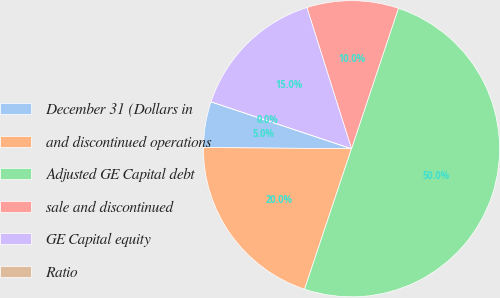Convert chart. <chart><loc_0><loc_0><loc_500><loc_500><pie_chart><fcel>December 31 (Dollars in<fcel>and discontinued operations<fcel>Adjusted GE Capital debt<fcel>sale and discontinued<fcel>GE Capital equity<fcel>Ratio<nl><fcel>5.0%<fcel>20.0%<fcel>50.0%<fcel>10.0%<fcel>15.0%<fcel>0.0%<nl></chart> 